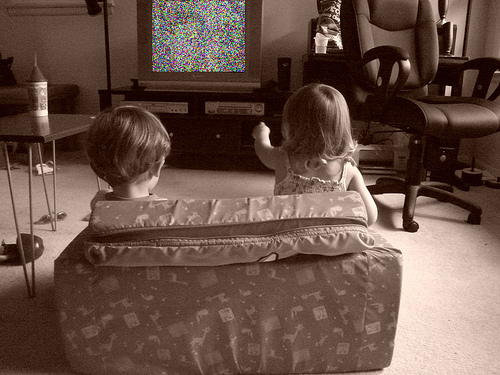What are the kids watching? It's unclear exactly what show or content the kids are watching as the TV screen shows static. The scene might represent a moment when they expected to watch their favorite program only to find technical issues or disruption in the signal. 